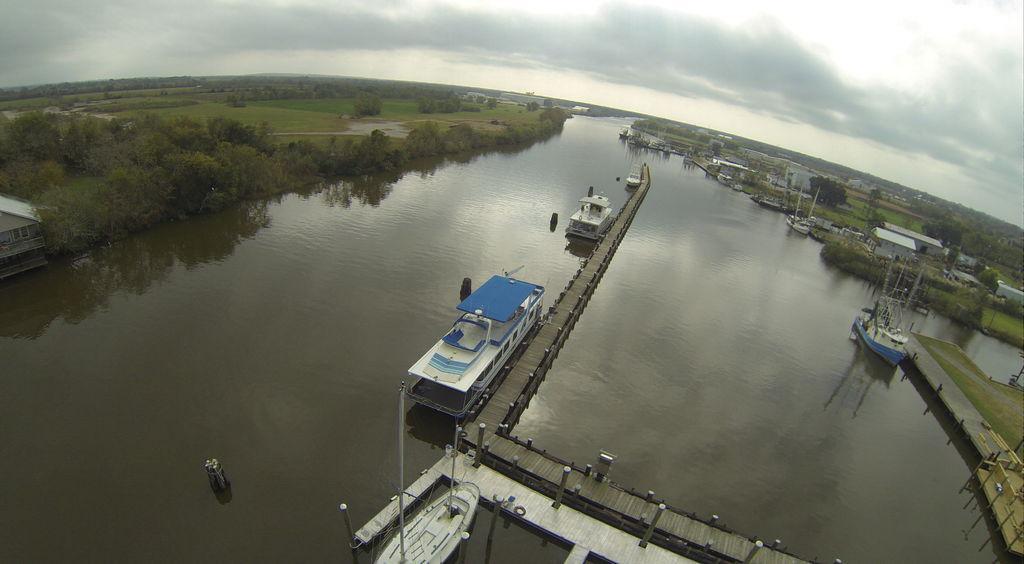Could you give a brief overview of what you see in this image? In this picture there are few boats on the water and there are trees on either sides of it and there are few buildings in the right corner. 